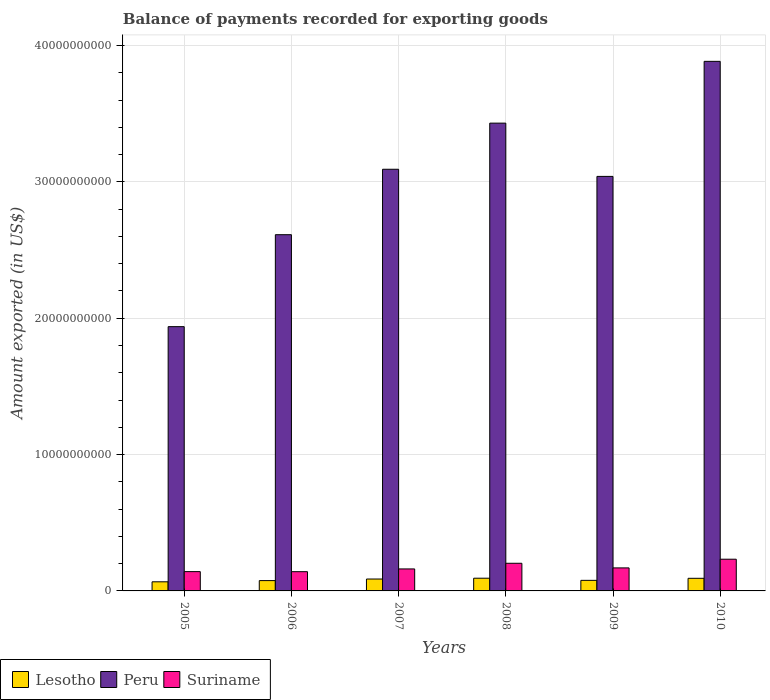Are the number of bars per tick equal to the number of legend labels?
Provide a short and direct response. Yes. Are the number of bars on each tick of the X-axis equal?
Give a very brief answer. Yes. What is the label of the 2nd group of bars from the left?
Offer a terse response. 2006. In how many cases, is the number of bars for a given year not equal to the number of legend labels?
Provide a short and direct response. 0. What is the amount exported in Suriname in 2005?
Keep it short and to the point. 1.42e+09. Across all years, what is the maximum amount exported in Suriname?
Make the answer very short. 2.33e+09. Across all years, what is the minimum amount exported in Lesotho?
Your answer should be compact. 6.68e+08. In which year was the amount exported in Peru minimum?
Your answer should be very brief. 2005. What is the total amount exported in Suriname in the graph?
Keep it short and to the point. 1.05e+1. What is the difference between the amount exported in Suriname in 2006 and that in 2007?
Keep it short and to the point. -2.01e+08. What is the difference between the amount exported in Suriname in 2008 and the amount exported in Peru in 2010?
Keep it short and to the point. -3.68e+1. What is the average amount exported in Lesotho per year?
Make the answer very short. 8.22e+08. In the year 2007, what is the difference between the amount exported in Lesotho and amount exported in Suriname?
Offer a terse response. -7.40e+08. What is the ratio of the amount exported in Peru in 2006 to that in 2008?
Provide a short and direct response. 0.76. Is the difference between the amount exported in Lesotho in 2006 and 2010 greater than the difference between the amount exported in Suriname in 2006 and 2010?
Provide a succinct answer. Yes. What is the difference between the highest and the second highest amount exported in Suriname?
Offer a terse response. 2.98e+08. What is the difference between the highest and the lowest amount exported in Lesotho?
Keep it short and to the point. 2.64e+08. Is the sum of the amount exported in Suriname in 2006 and 2009 greater than the maximum amount exported in Lesotho across all years?
Your answer should be compact. Yes. What does the 2nd bar from the left in 2005 represents?
Your answer should be very brief. Peru. What does the 3rd bar from the right in 2008 represents?
Make the answer very short. Lesotho. How many bars are there?
Ensure brevity in your answer.  18. Are all the bars in the graph horizontal?
Your response must be concise. No. What is the difference between two consecutive major ticks on the Y-axis?
Your answer should be very brief. 1.00e+1. Does the graph contain any zero values?
Your answer should be very brief. No. Does the graph contain grids?
Your answer should be very brief. Yes. How are the legend labels stacked?
Provide a short and direct response. Horizontal. What is the title of the graph?
Your answer should be very brief. Balance of payments recorded for exporting goods. What is the label or title of the Y-axis?
Your answer should be very brief. Amount exported (in US$). What is the Amount exported (in US$) in Lesotho in 2005?
Give a very brief answer. 6.68e+08. What is the Amount exported (in US$) in Peru in 2005?
Ensure brevity in your answer.  1.94e+1. What is the Amount exported (in US$) in Suriname in 2005?
Offer a very short reply. 1.42e+09. What is the Amount exported (in US$) in Lesotho in 2006?
Your answer should be very brief. 7.57e+08. What is the Amount exported (in US$) of Peru in 2006?
Give a very brief answer. 2.61e+1. What is the Amount exported (in US$) of Suriname in 2006?
Your response must be concise. 1.41e+09. What is the Amount exported (in US$) of Lesotho in 2007?
Provide a succinct answer. 8.72e+08. What is the Amount exported (in US$) in Peru in 2007?
Your answer should be very brief. 3.09e+1. What is the Amount exported (in US$) of Suriname in 2007?
Your answer should be compact. 1.61e+09. What is the Amount exported (in US$) in Lesotho in 2008?
Keep it short and to the point. 9.32e+08. What is the Amount exported (in US$) in Peru in 2008?
Your response must be concise. 3.43e+1. What is the Amount exported (in US$) in Suriname in 2008?
Offer a very short reply. 2.03e+09. What is the Amount exported (in US$) in Lesotho in 2009?
Your answer should be compact. 7.76e+08. What is the Amount exported (in US$) of Peru in 2009?
Keep it short and to the point. 3.04e+1. What is the Amount exported (in US$) in Suriname in 2009?
Your response must be concise. 1.69e+09. What is the Amount exported (in US$) of Lesotho in 2010?
Your answer should be compact. 9.25e+08. What is the Amount exported (in US$) of Peru in 2010?
Make the answer very short. 3.88e+1. What is the Amount exported (in US$) of Suriname in 2010?
Make the answer very short. 2.33e+09. Across all years, what is the maximum Amount exported (in US$) of Lesotho?
Your answer should be very brief. 9.32e+08. Across all years, what is the maximum Amount exported (in US$) of Peru?
Ensure brevity in your answer.  3.88e+1. Across all years, what is the maximum Amount exported (in US$) of Suriname?
Give a very brief answer. 2.33e+09. Across all years, what is the minimum Amount exported (in US$) in Lesotho?
Keep it short and to the point. 6.68e+08. Across all years, what is the minimum Amount exported (in US$) of Peru?
Provide a succinct answer. 1.94e+1. Across all years, what is the minimum Amount exported (in US$) in Suriname?
Provide a succinct answer. 1.41e+09. What is the total Amount exported (in US$) of Lesotho in the graph?
Provide a short and direct response. 4.93e+09. What is the total Amount exported (in US$) in Peru in the graph?
Keep it short and to the point. 1.80e+11. What is the total Amount exported (in US$) of Suriname in the graph?
Offer a terse response. 1.05e+1. What is the difference between the Amount exported (in US$) of Lesotho in 2005 and that in 2006?
Your answer should be compact. -8.89e+07. What is the difference between the Amount exported (in US$) of Peru in 2005 and that in 2006?
Keep it short and to the point. -6.74e+09. What is the difference between the Amount exported (in US$) of Suriname in 2005 and that in 2006?
Your response must be concise. 4.50e+06. What is the difference between the Amount exported (in US$) in Lesotho in 2005 and that in 2007?
Ensure brevity in your answer.  -2.04e+08. What is the difference between the Amount exported (in US$) of Peru in 2005 and that in 2007?
Provide a short and direct response. -1.15e+1. What is the difference between the Amount exported (in US$) in Suriname in 2005 and that in 2007?
Offer a very short reply. -1.97e+08. What is the difference between the Amount exported (in US$) in Lesotho in 2005 and that in 2008?
Give a very brief answer. -2.64e+08. What is the difference between the Amount exported (in US$) of Peru in 2005 and that in 2008?
Give a very brief answer. -1.49e+1. What is the difference between the Amount exported (in US$) in Suriname in 2005 and that in 2008?
Your response must be concise. -6.12e+08. What is the difference between the Amount exported (in US$) of Lesotho in 2005 and that in 2009?
Make the answer very short. -1.08e+08. What is the difference between the Amount exported (in US$) of Peru in 2005 and that in 2009?
Make the answer very short. -1.10e+1. What is the difference between the Amount exported (in US$) in Suriname in 2005 and that in 2009?
Ensure brevity in your answer.  -2.73e+08. What is the difference between the Amount exported (in US$) of Lesotho in 2005 and that in 2010?
Your answer should be very brief. -2.57e+08. What is the difference between the Amount exported (in US$) in Peru in 2005 and that in 2010?
Make the answer very short. -1.95e+1. What is the difference between the Amount exported (in US$) in Suriname in 2005 and that in 2010?
Keep it short and to the point. -9.10e+08. What is the difference between the Amount exported (in US$) in Lesotho in 2006 and that in 2007?
Provide a short and direct response. -1.15e+08. What is the difference between the Amount exported (in US$) in Peru in 2006 and that in 2007?
Your answer should be very brief. -4.80e+09. What is the difference between the Amount exported (in US$) in Suriname in 2006 and that in 2007?
Your response must be concise. -2.01e+08. What is the difference between the Amount exported (in US$) in Lesotho in 2006 and that in 2008?
Your response must be concise. -1.75e+08. What is the difference between the Amount exported (in US$) in Peru in 2006 and that in 2008?
Keep it short and to the point. -8.18e+09. What is the difference between the Amount exported (in US$) in Suriname in 2006 and that in 2008?
Offer a very short reply. -6.17e+08. What is the difference between the Amount exported (in US$) of Lesotho in 2006 and that in 2009?
Provide a succinct answer. -1.87e+07. What is the difference between the Amount exported (in US$) of Peru in 2006 and that in 2009?
Your response must be concise. -4.28e+09. What is the difference between the Amount exported (in US$) in Suriname in 2006 and that in 2009?
Your response must be concise. -2.77e+08. What is the difference between the Amount exported (in US$) in Lesotho in 2006 and that in 2010?
Keep it short and to the point. -1.68e+08. What is the difference between the Amount exported (in US$) of Peru in 2006 and that in 2010?
Offer a terse response. -1.27e+1. What is the difference between the Amount exported (in US$) in Suriname in 2006 and that in 2010?
Provide a succinct answer. -9.14e+08. What is the difference between the Amount exported (in US$) in Lesotho in 2007 and that in 2008?
Provide a short and direct response. -6.01e+07. What is the difference between the Amount exported (in US$) of Peru in 2007 and that in 2008?
Your answer should be very brief. -3.38e+09. What is the difference between the Amount exported (in US$) in Suriname in 2007 and that in 2008?
Your answer should be compact. -4.15e+08. What is the difference between the Amount exported (in US$) in Lesotho in 2007 and that in 2009?
Provide a short and direct response. 9.66e+07. What is the difference between the Amount exported (in US$) of Peru in 2007 and that in 2009?
Ensure brevity in your answer.  5.23e+08. What is the difference between the Amount exported (in US$) in Suriname in 2007 and that in 2009?
Your answer should be very brief. -7.61e+07. What is the difference between the Amount exported (in US$) of Lesotho in 2007 and that in 2010?
Make the answer very short. -5.31e+07. What is the difference between the Amount exported (in US$) in Peru in 2007 and that in 2010?
Make the answer very short. -7.91e+09. What is the difference between the Amount exported (in US$) of Suriname in 2007 and that in 2010?
Provide a short and direct response. -7.13e+08. What is the difference between the Amount exported (in US$) in Lesotho in 2008 and that in 2009?
Give a very brief answer. 1.57e+08. What is the difference between the Amount exported (in US$) in Peru in 2008 and that in 2009?
Make the answer very short. 3.91e+09. What is the difference between the Amount exported (in US$) in Suriname in 2008 and that in 2009?
Offer a terse response. 3.39e+08. What is the difference between the Amount exported (in US$) of Lesotho in 2008 and that in 2010?
Provide a short and direct response. 7.00e+06. What is the difference between the Amount exported (in US$) in Peru in 2008 and that in 2010?
Your answer should be very brief. -4.53e+09. What is the difference between the Amount exported (in US$) in Suriname in 2008 and that in 2010?
Your answer should be compact. -2.98e+08. What is the difference between the Amount exported (in US$) in Lesotho in 2009 and that in 2010?
Your answer should be compact. -1.50e+08. What is the difference between the Amount exported (in US$) of Peru in 2009 and that in 2010?
Your response must be concise. -8.44e+09. What is the difference between the Amount exported (in US$) in Suriname in 2009 and that in 2010?
Keep it short and to the point. -6.37e+08. What is the difference between the Amount exported (in US$) in Lesotho in 2005 and the Amount exported (in US$) in Peru in 2006?
Your answer should be compact. -2.55e+1. What is the difference between the Amount exported (in US$) of Lesotho in 2005 and the Amount exported (in US$) of Suriname in 2006?
Give a very brief answer. -7.43e+08. What is the difference between the Amount exported (in US$) in Peru in 2005 and the Amount exported (in US$) in Suriname in 2006?
Offer a very short reply. 1.80e+1. What is the difference between the Amount exported (in US$) of Lesotho in 2005 and the Amount exported (in US$) of Peru in 2007?
Give a very brief answer. -3.03e+1. What is the difference between the Amount exported (in US$) of Lesotho in 2005 and the Amount exported (in US$) of Suriname in 2007?
Give a very brief answer. -9.44e+08. What is the difference between the Amount exported (in US$) of Peru in 2005 and the Amount exported (in US$) of Suriname in 2007?
Provide a succinct answer. 1.78e+1. What is the difference between the Amount exported (in US$) of Lesotho in 2005 and the Amount exported (in US$) of Peru in 2008?
Ensure brevity in your answer.  -3.36e+1. What is the difference between the Amount exported (in US$) of Lesotho in 2005 and the Amount exported (in US$) of Suriname in 2008?
Your response must be concise. -1.36e+09. What is the difference between the Amount exported (in US$) of Peru in 2005 and the Amount exported (in US$) of Suriname in 2008?
Ensure brevity in your answer.  1.74e+1. What is the difference between the Amount exported (in US$) of Lesotho in 2005 and the Amount exported (in US$) of Peru in 2009?
Offer a very short reply. -2.97e+1. What is the difference between the Amount exported (in US$) of Lesotho in 2005 and the Amount exported (in US$) of Suriname in 2009?
Give a very brief answer. -1.02e+09. What is the difference between the Amount exported (in US$) in Peru in 2005 and the Amount exported (in US$) in Suriname in 2009?
Your answer should be very brief. 1.77e+1. What is the difference between the Amount exported (in US$) of Lesotho in 2005 and the Amount exported (in US$) of Peru in 2010?
Give a very brief answer. -3.82e+1. What is the difference between the Amount exported (in US$) in Lesotho in 2005 and the Amount exported (in US$) in Suriname in 2010?
Provide a succinct answer. -1.66e+09. What is the difference between the Amount exported (in US$) in Peru in 2005 and the Amount exported (in US$) in Suriname in 2010?
Your response must be concise. 1.71e+1. What is the difference between the Amount exported (in US$) of Lesotho in 2006 and the Amount exported (in US$) of Peru in 2007?
Your answer should be compact. -3.02e+1. What is the difference between the Amount exported (in US$) of Lesotho in 2006 and the Amount exported (in US$) of Suriname in 2007?
Give a very brief answer. -8.55e+08. What is the difference between the Amount exported (in US$) in Peru in 2006 and the Amount exported (in US$) in Suriname in 2007?
Ensure brevity in your answer.  2.45e+1. What is the difference between the Amount exported (in US$) in Lesotho in 2006 and the Amount exported (in US$) in Peru in 2008?
Make the answer very short. -3.35e+1. What is the difference between the Amount exported (in US$) in Lesotho in 2006 and the Amount exported (in US$) in Suriname in 2008?
Offer a very short reply. -1.27e+09. What is the difference between the Amount exported (in US$) of Peru in 2006 and the Amount exported (in US$) of Suriname in 2008?
Provide a short and direct response. 2.41e+1. What is the difference between the Amount exported (in US$) of Lesotho in 2006 and the Amount exported (in US$) of Peru in 2009?
Offer a very short reply. -2.96e+1. What is the difference between the Amount exported (in US$) of Lesotho in 2006 and the Amount exported (in US$) of Suriname in 2009?
Your answer should be compact. -9.32e+08. What is the difference between the Amount exported (in US$) of Peru in 2006 and the Amount exported (in US$) of Suriname in 2009?
Your response must be concise. 2.44e+1. What is the difference between the Amount exported (in US$) of Lesotho in 2006 and the Amount exported (in US$) of Peru in 2010?
Your answer should be compact. -3.81e+1. What is the difference between the Amount exported (in US$) of Lesotho in 2006 and the Amount exported (in US$) of Suriname in 2010?
Your response must be concise. -1.57e+09. What is the difference between the Amount exported (in US$) of Peru in 2006 and the Amount exported (in US$) of Suriname in 2010?
Offer a very short reply. 2.38e+1. What is the difference between the Amount exported (in US$) of Lesotho in 2007 and the Amount exported (in US$) of Peru in 2008?
Your response must be concise. -3.34e+1. What is the difference between the Amount exported (in US$) in Lesotho in 2007 and the Amount exported (in US$) in Suriname in 2008?
Offer a very short reply. -1.16e+09. What is the difference between the Amount exported (in US$) of Peru in 2007 and the Amount exported (in US$) of Suriname in 2008?
Make the answer very short. 2.89e+1. What is the difference between the Amount exported (in US$) of Lesotho in 2007 and the Amount exported (in US$) of Peru in 2009?
Your answer should be compact. -2.95e+1. What is the difference between the Amount exported (in US$) in Lesotho in 2007 and the Amount exported (in US$) in Suriname in 2009?
Your answer should be compact. -8.16e+08. What is the difference between the Amount exported (in US$) in Peru in 2007 and the Amount exported (in US$) in Suriname in 2009?
Your response must be concise. 2.92e+1. What is the difference between the Amount exported (in US$) in Lesotho in 2007 and the Amount exported (in US$) in Peru in 2010?
Provide a short and direct response. -3.80e+1. What is the difference between the Amount exported (in US$) of Lesotho in 2007 and the Amount exported (in US$) of Suriname in 2010?
Your answer should be very brief. -1.45e+09. What is the difference between the Amount exported (in US$) in Peru in 2007 and the Amount exported (in US$) in Suriname in 2010?
Keep it short and to the point. 2.86e+1. What is the difference between the Amount exported (in US$) in Lesotho in 2008 and the Amount exported (in US$) in Peru in 2009?
Keep it short and to the point. -2.95e+1. What is the difference between the Amount exported (in US$) of Lesotho in 2008 and the Amount exported (in US$) of Suriname in 2009?
Ensure brevity in your answer.  -7.56e+08. What is the difference between the Amount exported (in US$) in Peru in 2008 and the Amount exported (in US$) in Suriname in 2009?
Provide a short and direct response. 3.26e+1. What is the difference between the Amount exported (in US$) in Lesotho in 2008 and the Amount exported (in US$) in Peru in 2010?
Provide a succinct answer. -3.79e+1. What is the difference between the Amount exported (in US$) in Lesotho in 2008 and the Amount exported (in US$) in Suriname in 2010?
Offer a very short reply. -1.39e+09. What is the difference between the Amount exported (in US$) in Peru in 2008 and the Amount exported (in US$) in Suriname in 2010?
Make the answer very short. 3.20e+1. What is the difference between the Amount exported (in US$) of Lesotho in 2009 and the Amount exported (in US$) of Peru in 2010?
Offer a terse response. -3.81e+1. What is the difference between the Amount exported (in US$) of Lesotho in 2009 and the Amount exported (in US$) of Suriname in 2010?
Your answer should be compact. -1.55e+09. What is the difference between the Amount exported (in US$) of Peru in 2009 and the Amount exported (in US$) of Suriname in 2010?
Your answer should be compact. 2.81e+1. What is the average Amount exported (in US$) in Lesotho per year?
Provide a short and direct response. 8.22e+08. What is the average Amount exported (in US$) in Peru per year?
Offer a terse response. 3.00e+1. What is the average Amount exported (in US$) of Suriname per year?
Provide a short and direct response. 1.75e+09. In the year 2005, what is the difference between the Amount exported (in US$) in Lesotho and Amount exported (in US$) in Peru?
Your answer should be compact. -1.87e+1. In the year 2005, what is the difference between the Amount exported (in US$) of Lesotho and Amount exported (in US$) of Suriname?
Your answer should be compact. -7.48e+08. In the year 2005, what is the difference between the Amount exported (in US$) in Peru and Amount exported (in US$) in Suriname?
Keep it short and to the point. 1.80e+1. In the year 2006, what is the difference between the Amount exported (in US$) of Lesotho and Amount exported (in US$) of Peru?
Offer a terse response. -2.54e+1. In the year 2006, what is the difference between the Amount exported (in US$) in Lesotho and Amount exported (in US$) in Suriname?
Your answer should be compact. -6.54e+08. In the year 2006, what is the difference between the Amount exported (in US$) of Peru and Amount exported (in US$) of Suriname?
Offer a very short reply. 2.47e+1. In the year 2007, what is the difference between the Amount exported (in US$) in Lesotho and Amount exported (in US$) in Peru?
Your response must be concise. -3.01e+1. In the year 2007, what is the difference between the Amount exported (in US$) in Lesotho and Amount exported (in US$) in Suriname?
Offer a terse response. -7.40e+08. In the year 2007, what is the difference between the Amount exported (in US$) in Peru and Amount exported (in US$) in Suriname?
Provide a short and direct response. 2.93e+1. In the year 2008, what is the difference between the Amount exported (in US$) in Lesotho and Amount exported (in US$) in Peru?
Make the answer very short. -3.34e+1. In the year 2008, what is the difference between the Amount exported (in US$) in Lesotho and Amount exported (in US$) in Suriname?
Your response must be concise. -1.10e+09. In the year 2008, what is the difference between the Amount exported (in US$) in Peru and Amount exported (in US$) in Suriname?
Give a very brief answer. 3.23e+1. In the year 2009, what is the difference between the Amount exported (in US$) in Lesotho and Amount exported (in US$) in Peru?
Your response must be concise. -2.96e+1. In the year 2009, what is the difference between the Amount exported (in US$) of Lesotho and Amount exported (in US$) of Suriname?
Give a very brief answer. -9.13e+08. In the year 2009, what is the difference between the Amount exported (in US$) of Peru and Amount exported (in US$) of Suriname?
Offer a terse response. 2.87e+1. In the year 2010, what is the difference between the Amount exported (in US$) of Lesotho and Amount exported (in US$) of Peru?
Give a very brief answer. -3.79e+1. In the year 2010, what is the difference between the Amount exported (in US$) of Lesotho and Amount exported (in US$) of Suriname?
Provide a succinct answer. -1.40e+09. In the year 2010, what is the difference between the Amount exported (in US$) of Peru and Amount exported (in US$) of Suriname?
Ensure brevity in your answer.  3.65e+1. What is the ratio of the Amount exported (in US$) of Lesotho in 2005 to that in 2006?
Provide a short and direct response. 0.88. What is the ratio of the Amount exported (in US$) of Peru in 2005 to that in 2006?
Ensure brevity in your answer.  0.74. What is the ratio of the Amount exported (in US$) of Suriname in 2005 to that in 2006?
Provide a succinct answer. 1. What is the ratio of the Amount exported (in US$) in Lesotho in 2005 to that in 2007?
Ensure brevity in your answer.  0.77. What is the ratio of the Amount exported (in US$) in Peru in 2005 to that in 2007?
Offer a very short reply. 0.63. What is the ratio of the Amount exported (in US$) of Suriname in 2005 to that in 2007?
Provide a short and direct response. 0.88. What is the ratio of the Amount exported (in US$) in Lesotho in 2005 to that in 2008?
Provide a succinct answer. 0.72. What is the ratio of the Amount exported (in US$) in Peru in 2005 to that in 2008?
Give a very brief answer. 0.56. What is the ratio of the Amount exported (in US$) in Suriname in 2005 to that in 2008?
Your answer should be very brief. 0.7. What is the ratio of the Amount exported (in US$) in Lesotho in 2005 to that in 2009?
Ensure brevity in your answer.  0.86. What is the ratio of the Amount exported (in US$) of Peru in 2005 to that in 2009?
Keep it short and to the point. 0.64. What is the ratio of the Amount exported (in US$) of Suriname in 2005 to that in 2009?
Your response must be concise. 0.84. What is the ratio of the Amount exported (in US$) of Lesotho in 2005 to that in 2010?
Ensure brevity in your answer.  0.72. What is the ratio of the Amount exported (in US$) of Peru in 2005 to that in 2010?
Provide a short and direct response. 0.5. What is the ratio of the Amount exported (in US$) in Suriname in 2005 to that in 2010?
Your answer should be very brief. 0.61. What is the ratio of the Amount exported (in US$) of Lesotho in 2006 to that in 2007?
Make the answer very short. 0.87. What is the ratio of the Amount exported (in US$) in Peru in 2006 to that in 2007?
Your answer should be compact. 0.84. What is the ratio of the Amount exported (in US$) of Suriname in 2006 to that in 2007?
Make the answer very short. 0.88. What is the ratio of the Amount exported (in US$) of Lesotho in 2006 to that in 2008?
Your answer should be compact. 0.81. What is the ratio of the Amount exported (in US$) in Peru in 2006 to that in 2008?
Offer a terse response. 0.76. What is the ratio of the Amount exported (in US$) in Suriname in 2006 to that in 2008?
Make the answer very short. 0.7. What is the ratio of the Amount exported (in US$) in Lesotho in 2006 to that in 2009?
Make the answer very short. 0.98. What is the ratio of the Amount exported (in US$) of Peru in 2006 to that in 2009?
Offer a terse response. 0.86. What is the ratio of the Amount exported (in US$) in Suriname in 2006 to that in 2009?
Ensure brevity in your answer.  0.84. What is the ratio of the Amount exported (in US$) in Lesotho in 2006 to that in 2010?
Make the answer very short. 0.82. What is the ratio of the Amount exported (in US$) of Peru in 2006 to that in 2010?
Provide a short and direct response. 0.67. What is the ratio of the Amount exported (in US$) in Suriname in 2006 to that in 2010?
Give a very brief answer. 0.61. What is the ratio of the Amount exported (in US$) in Lesotho in 2007 to that in 2008?
Keep it short and to the point. 0.94. What is the ratio of the Amount exported (in US$) in Peru in 2007 to that in 2008?
Your answer should be very brief. 0.9. What is the ratio of the Amount exported (in US$) of Suriname in 2007 to that in 2008?
Provide a succinct answer. 0.8. What is the ratio of the Amount exported (in US$) in Lesotho in 2007 to that in 2009?
Provide a succinct answer. 1.12. What is the ratio of the Amount exported (in US$) in Peru in 2007 to that in 2009?
Give a very brief answer. 1.02. What is the ratio of the Amount exported (in US$) in Suriname in 2007 to that in 2009?
Your response must be concise. 0.95. What is the ratio of the Amount exported (in US$) of Lesotho in 2007 to that in 2010?
Give a very brief answer. 0.94. What is the ratio of the Amount exported (in US$) of Peru in 2007 to that in 2010?
Keep it short and to the point. 0.8. What is the ratio of the Amount exported (in US$) of Suriname in 2007 to that in 2010?
Give a very brief answer. 0.69. What is the ratio of the Amount exported (in US$) of Lesotho in 2008 to that in 2009?
Give a very brief answer. 1.2. What is the ratio of the Amount exported (in US$) in Peru in 2008 to that in 2009?
Keep it short and to the point. 1.13. What is the ratio of the Amount exported (in US$) in Suriname in 2008 to that in 2009?
Make the answer very short. 1.2. What is the ratio of the Amount exported (in US$) in Lesotho in 2008 to that in 2010?
Give a very brief answer. 1.01. What is the ratio of the Amount exported (in US$) in Peru in 2008 to that in 2010?
Your answer should be very brief. 0.88. What is the ratio of the Amount exported (in US$) in Suriname in 2008 to that in 2010?
Give a very brief answer. 0.87. What is the ratio of the Amount exported (in US$) of Lesotho in 2009 to that in 2010?
Your response must be concise. 0.84. What is the ratio of the Amount exported (in US$) of Peru in 2009 to that in 2010?
Offer a terse response. 0.78. What is the ratio of the Amount exported (in US$) of Suriname in 2009 to that in 2010?
Offer a very short reply. 0.73. What is the difference between the highest and the second highest Amount exported (in US$) in Lesotho?
Your answer should be very brief. 7.00e+06. What is the difference between the highest and the second highest Amount exported (in US$) of Peru?
Provide a short and direct response. 4.53e+09. What is the difference between the highest and the second highest Amount exported (in US$) in Suriname?
Your answer should be very brief. 2.98e+08. What is the difference between the highest and the lowest Amount exported (in US$) in Lesotho?
Offer a terse response. 2.64e+08. What is the difference between the highest and the lowest Amount exported (in US$) of Peru?
Provide a succinct answer. 1.95e+1. What is the difference between the highest and the lowest Amount exported (in US$) in Suriname?
Make the answer very short. 9.14e+08. 